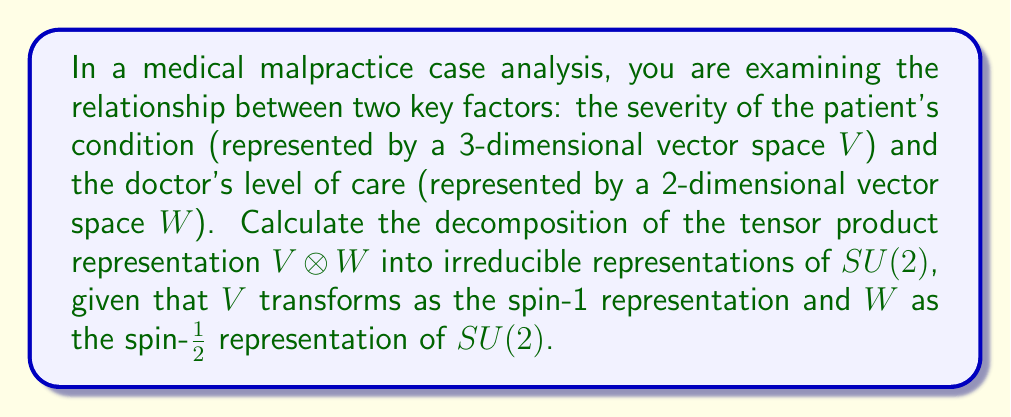Can you answer this question? To decompose the tensor product representation $V \otimes W$, we follow these steps:

1) Identify the representations:
   $V$ is a spin-1 representation (dimension 3)
   $W$ is a spin-1/2 representation (dimension 2)

2) Recall the Clebsch-Gordan decomposition formula for $SU(2)$:
   $$ j_1 \otimes j_2 = |j_1 - j_2| \oplus (|j_1 - j_2| + 1) \oplus ... \oplus (j_1 + j_2) $$

3) In this case:
   $j_1 = 1$ (for $V$)
   $j_2 = 1/2$ (for $W$)

4) Apply the formula:
   $$ 1 \otimes 1/2 = |1 - 1/2| \oplus (|1 - 1/2| + 1) $$
   $$ = 1/2 \oplus 3/2 $$

5) Interpret the result:
   - The 1/2 represents a 2-dimensional irreducible representation
   - The 3/2 represents a 4-dimensional irreducible representation

6) Check dimensions:
   dim($V \otimes W$) = dim($V$) × dim($W$) = 3 × 2 = 6
   dim(1/2) + dim(3/2) = 2 + 4 = 6

Therefore, the tensor product decomposes into the direct sum of a spin-1/2 and a spin-3/2 representation.
Answer: $V \otimes W = \frac{1}{2} \oplus \frac{3}{2}$ 